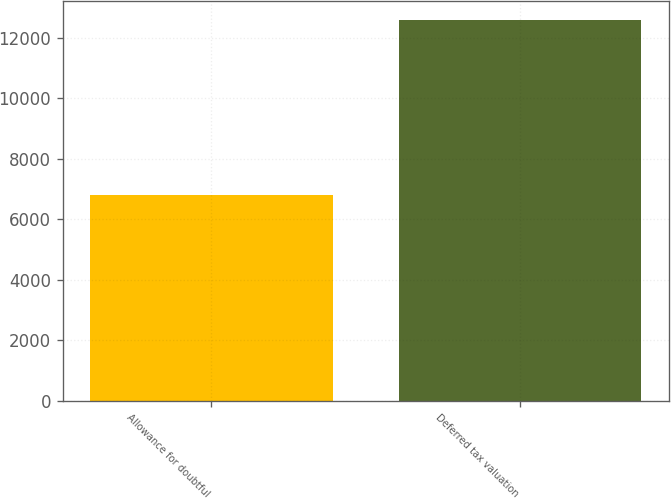Convert chart. <chart><loc_0><loc_0><loc_500><loc_500><bar_chart><fcel>Allowance for doubtful<fcel>Deferred tax valuation<nl><fcel>6795<fcel>12592<nl></chart> 